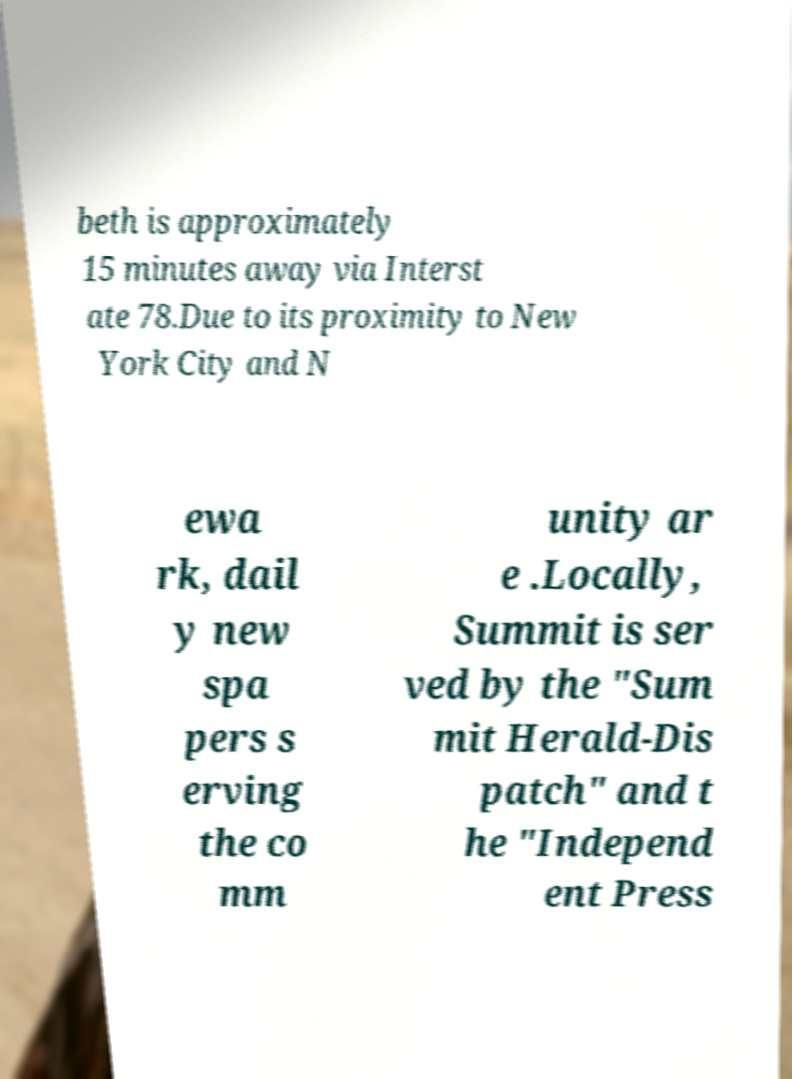There's text embedded in this image that I need extracted. Can you transcribe it verbatim? beth is approximately 15 minutes away via Interst ate 78.Due to its proximity to New York City and N ewa rk, dail y new spa pers s erving the co mm unity ar e .Locally, Summit is ser ved by the "Sum mit Herald-Dis patch" and t he "Independ ent Press 